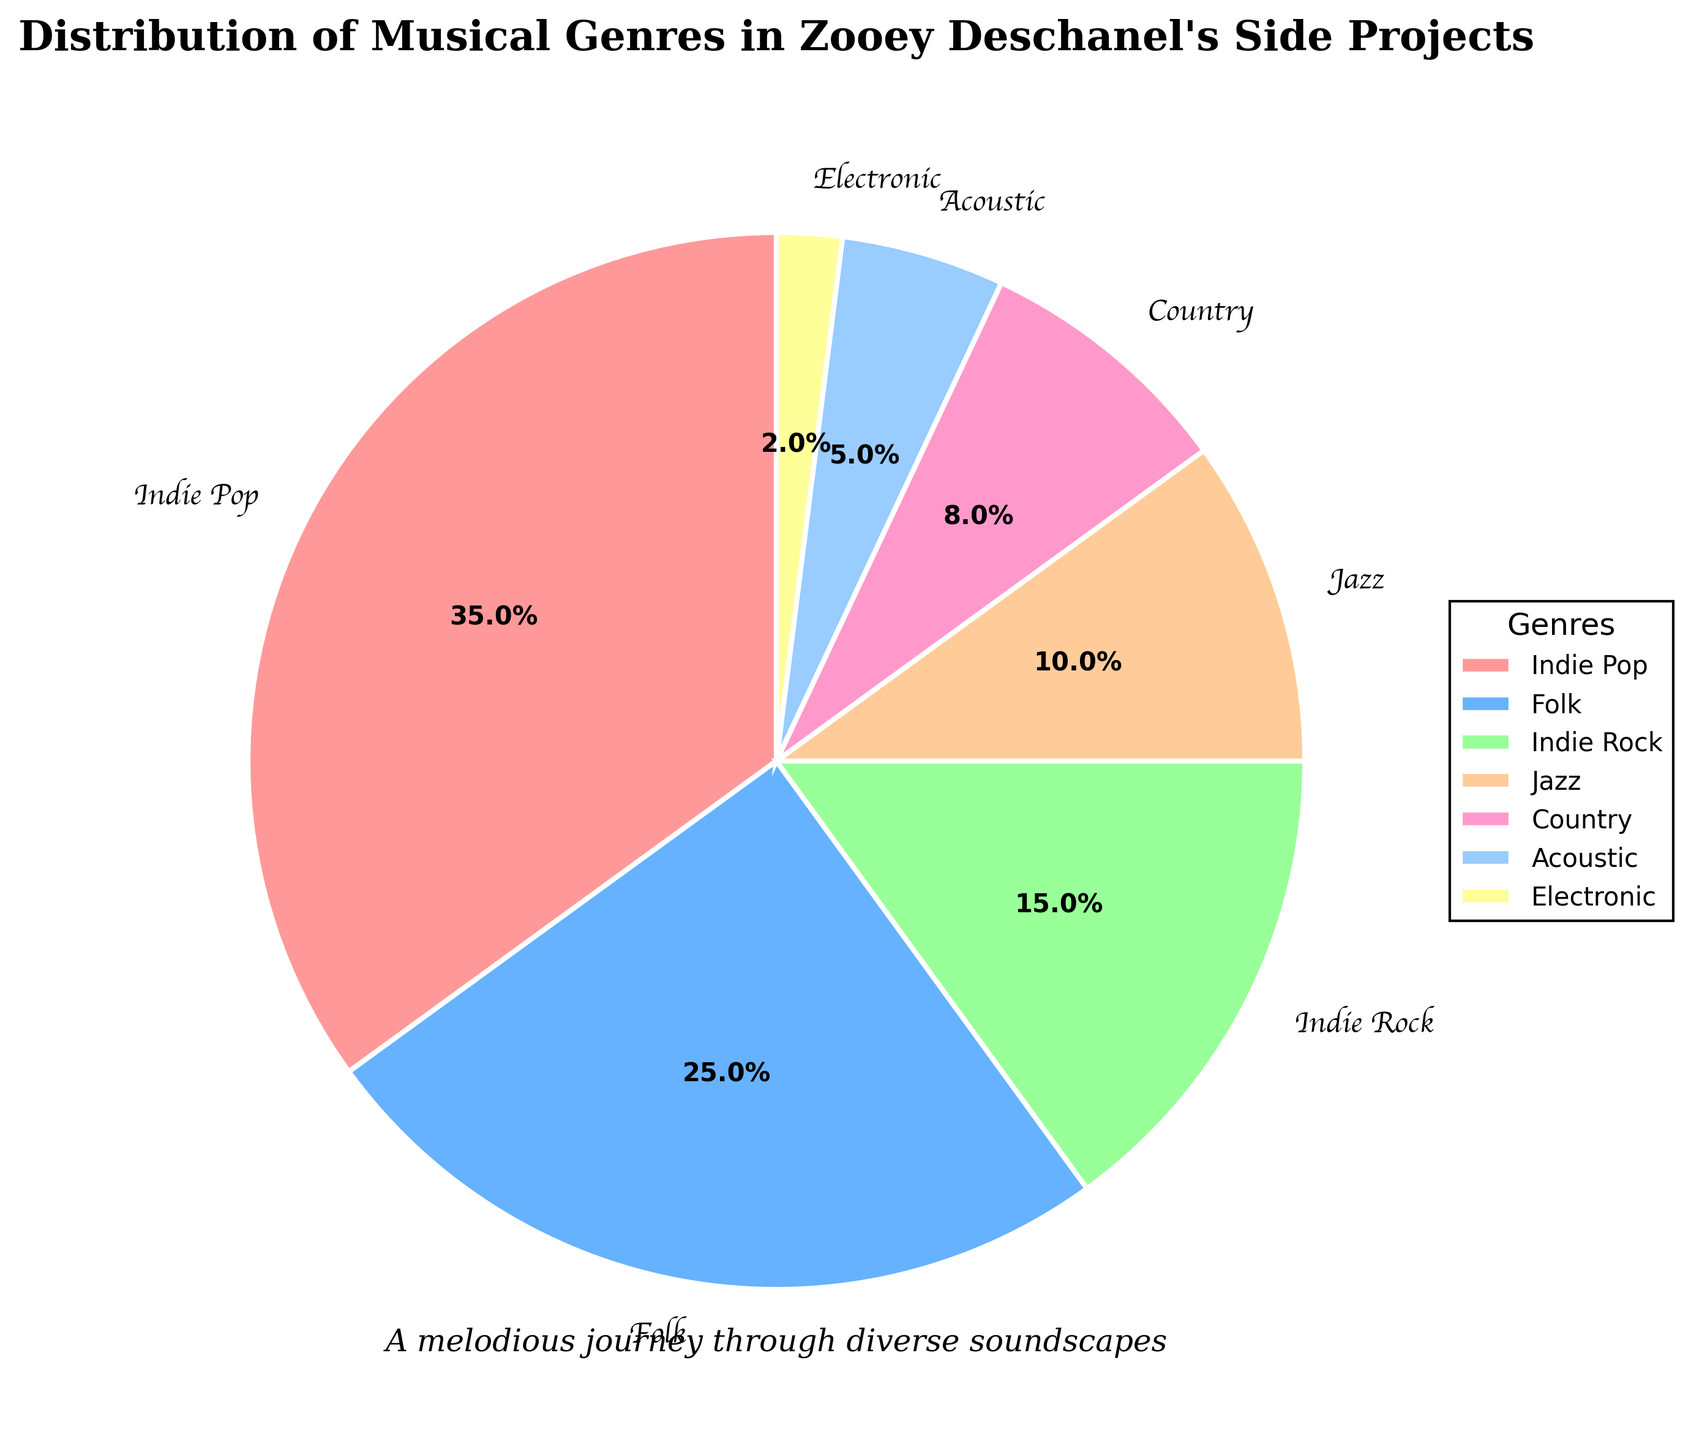What genre has the largest percentage? The pie chart shows different segments with associated percentages. The largest segment represents Indie Pop with 35%.
Answer: Indie Pop Which genre has a smaller percentage, Jazz or Country? As per the pie chart, Jazz has 10% and Country has 8%. So, the percentage for Country is smaller.
Answer: Country What is the total percentage of Indie Rock and Acoustic combined? The chart shows Indie Rock at 15% and Acoustic at 5%. Adding these together: 15% + 5% = 20%.
Answer: 20% How much more is the percentage of Indie Pop compared to Electronic? Indie Pop has 35% while Electronic has 2%. Subtracting these: 35% - 2% = 33%.
Answer: 33% Which segment is represented by a pinkish color in the pie chart? The pie chart uses different colors for each genre, and the segment with a pinkish color corresponds to Indie Pop.
Answer: Indie Pop What is the total percentage of all folk-related genres (Folk + Country + Acoustic)? The percentages for Folk, Country, and Acoustic are 25%, 8%, and 5%. Adding these together: 25% + 8% + 5% = 38%.
Answer: 38% Which genre appears directly to the right of Indie Rock in the pie chart? The sectors of the pie chart are arranged clockwise starting from the top. Since this arrangement is not specified numerically, visually checking from the chart, the genre directly to the right of Indie Rock is Jazz.
Answer: Jazz 